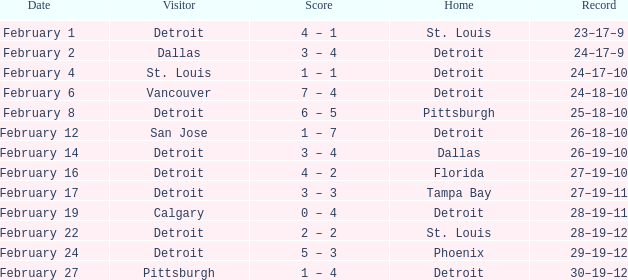While they were at pittsburgh, what was their record like? 25–18–10. 